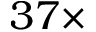<formula> <loc_0><loc_0><loc_500><loc_500>3 7 \times</formula> 